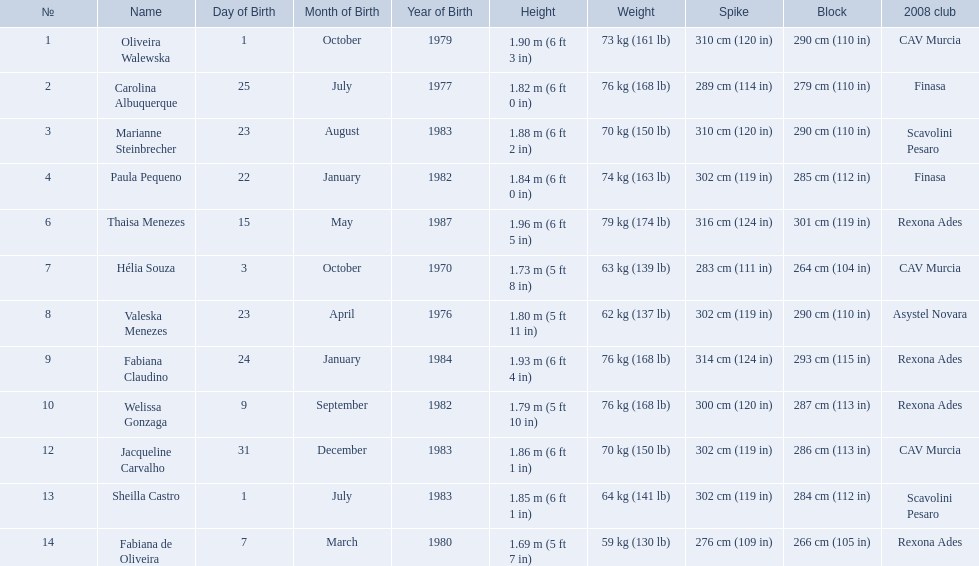What are all of the names? Oliveira Walewska, Carolina Albuquerque, Marianne Steinbrecher, Paula Pequeno, Thaisa Menezes, Hélia Souza, Valeska Menezes, Fabiana Claudino, Welissa Gonzaga, Jacqueline Carvalho, Sheilla Castro, Fabiana de Oliveira. What are their weights? 73 kg (161 lb), 76 kg (168 lb), 70 kg (150 lb), 74 kg (163 lb), 79 kg (174 lb), 63 kg (139 lb), 62 kg (137 lb), 76 kg (168 lb), 76 kg (168 lb), 70 kg (150 lb), 64 kg (141 lb), 59 kg (130 lb). Parse the table in full. {'header': ['№', 'Name', 'Day of Birth', 'Month of Birth', 'Year of Birth', 'Height', 'Weight', 'Spike', 'Block', '2008 club'], 'rows': [['1', 'Oliveira Walewska', '1', 'October', '1979', '1.90\xa0m (6\xa0ft 3\xa0in)', '73\xa0kg (161\xa0lb)', '310\xa0cm (120\xa0in)', '290\xa0cm (110\xa0in)', 'CAV Murcia'], ['2', 'Carolina Albuquerque', '25', 'July', '1977', '1.82\xa0m (6\xa0ft 0\xa0in)', '76\xa0kg (168\xa0lb)', '289\xa0cm (114\xa0in)', '279\xa0cm (110\xa0in)', 'Finasa'], ['3', 'Marianne Steinbrecher', '23', 'August', '1983', '1.88\xa0m (6\xa0ft 2\xa0in)', '70\xa0kg (150\xa0lb)', '310\xa0cm (120\xa0in)', '290\xa0cm (110\xa0in)', 'Scavolini Pesaro'], ['4', 'Paula Pequeno', '22', 'January', '1982', '1.84\xa0m (6\xa0ft 0\xa0in)', '74\xa0kg (163\xa0lb)', '302\xa0cm (119\xa0in)', '285\xa0cm (112\xa0in)', 'Finasa'], ['6', 'Thaisa Menezes', '15', 'May', '1987', '1.96\xa0m (6\xa0ft 5\xa0in)', '79\xa0kg (174\xa0lb)', '316\xa0cm (124\xa0in)', '301\xa0cm (119\xa0in)', 'Rexona Ades'], ['7', 'Hélia Souza', '3', 'October', '1970', '1.73\xa0m (5\xa0ft 8\xa0in)', '63\xa0kg (139\xa0lb)', '283\xa0cm (111\xa0in)', '264\xa0cm (104\xa0in)', 'CAV Murcia'], ['8', 'Valeska Menezes', '23', 'April', '1976', '1.80\xa0m (5\xa0ft 11\xa0in)', '62\xa0kg (137\xa0lb)', '302\xa0cm (119\xa0in)', '290\xa0cm (110\xa0in)', 'Asystel Novara'], ['9', 'Fabiana Claudino', '24', 'January', '1984', '1.93\xa0m (6\xa0ft 4\xa0in)', '76\xa0kg (168\xa0lb)', '314\xa0cm (124\xa0in)', '293\xa0cm (115\xa0in)', 'Rexona Ades'], ['10', 'Welissa Gonzaga', '9', 'September', '1982', '1.79\xa0m (5\xa0ft 10\xa0in)', '76\xa0kg (168\xa0lb)', '300\xa0cm (120\xa0in)', '287\xa0cm (113\xa0in)', 'Rexona Ades'], ['12', 'Jacqueline Carvalho', '31', 'December', '1983', '1.86\xa0m (6\xa0ft 1\xa0in)', '70\xa0kg (150\xa0lb)', '302\xa0cm (119\xa0in)', '286\xa0cm (113\xa0in)', 'CAV Murcia'], ['13', 'Sheilla Castro', '1', 'July', '1983', '1.85\xa0m (6\xa0ft 1\xa0in)', '64\xa0kg (141\xa0lb)', '302\xa0cm (119\xa0in)', '284\xa0cm (112\xa0in)', 'Scavolini Pesaro'], ['14', 'Fabiana de Oliveira', '7', 'March', '1980', '1.69\xa0m (5\xa0ft 7\xa0in)', '59\xa0kg (130\xa0lb)', '276\xa0cm (109\xa0in)', '266\xa0cm (105\xa0in)', 'Rexona Ades']]} How much did helia souza, fabiana de oliveira, and sheilla castro weigh? Hélia Souza, Sheilla Castro, Fabiana de Oliveira. And who weighed more? Sheilla Castro. 